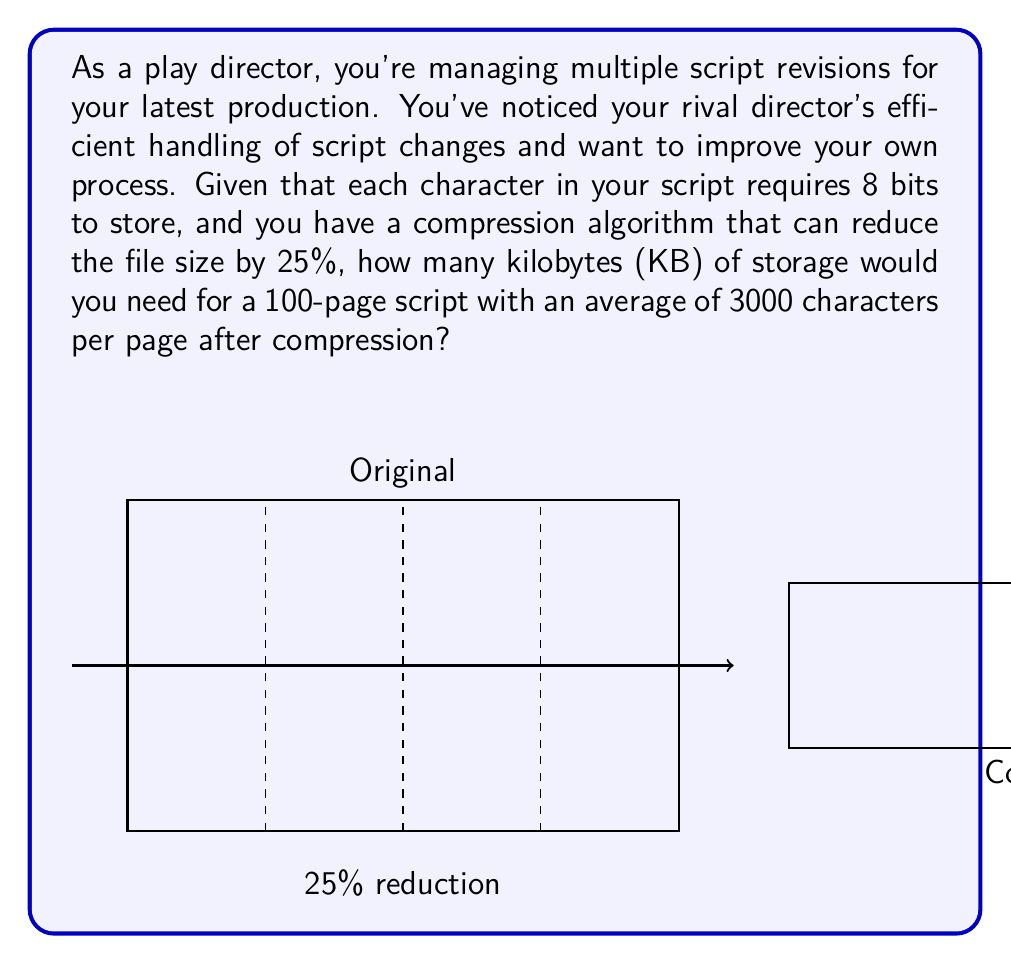Could you help me with this problem? Let's break this down step-by-step:

1) First, calculate the total number of characters in the script:
   $$ 100 \text{ pages} \times 3000 \text{ characters/page} = 300,000 \text{ characters} $$

2) Each character requires 8 bits to store. Calculate the total number of bits:
   $$ 300,000 \text{ characters} \times 8 \text{ bits/character} = 2,400,000 \text{ bits} $$

3) Convert bits to bytes:
   $$ 2,400,000 \text{ bits} \div 8 \text{ bits/byte} = 300,000 \text{ bytes} $$

4) Apply the compression algorithm. It reduces the file size by 25%, so we keep 75% of the original size:
   $$ 300,000 \text{ bytes} \times 0.75 = 225,000 \text{ bytes} $$

5) Convert bytes to kilobytes:
   $$ 225,000 \text{ bytes} \div 1024 \text{ bytes/KB} \approx 219.73 \text{ KB} $$

6) Round to the nearest whole number:
   $$ 219.73 \text{ KB} \approx 220 \text{ KB} $$
Answer: 220 KB 